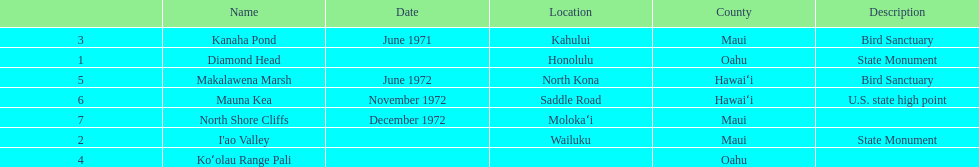How many images are listed? 6. 